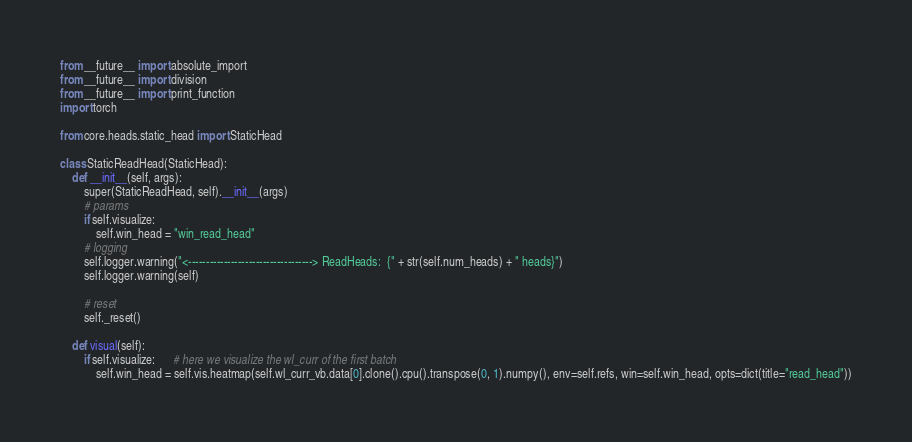Convert code to text. <code><loc_0><loc_0><loc_500><loc_500><_Python_>from __future__ import absolute_import
from __future__ import division
from __future__ import print_function
import torch

from core.heads.static_head import StaticHead

class StaticReadHead(StaticHead):
    def __init__(self, args):
        super(StaticReadHead, self).__init__(args)
        # params
        if self.visualize:
            self.win_head = "win_read_head"
        # logging
        self.logger.warning("<-----------------------------------> ReadHeads:  {" + str(self.num_heads) + " heads}")
        self.logger.warning(self)

        # reset
        self._reset()

    def visual(self):
        if self.visualize:      # here we visualize the wl_curr of the first batch
            self.win_head = self.vis.heatmap(self.wl_curr_vb.data[0].clone().cpu().transpose(0, 1).numpy(), env=self.refs, win=self.win_head, opts=dict(title="read_head"))
</code> 